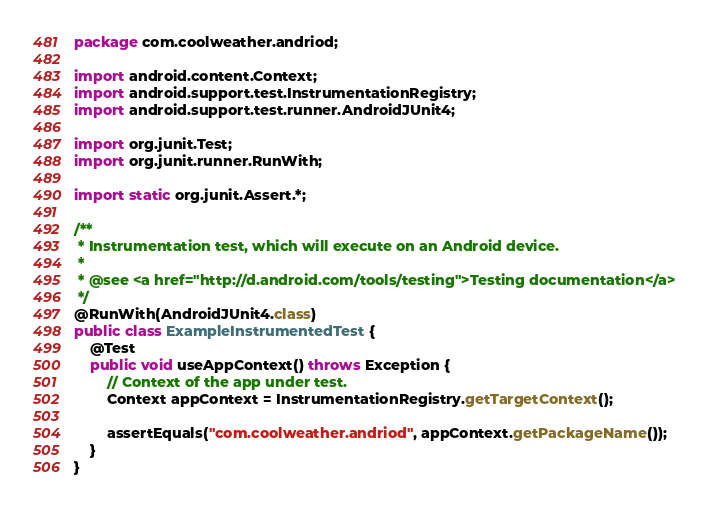Convert code to text. <code><loc_0><loc_0><loc_500><loc_500><_Java_>package com.coolweather.andriod;

import android.content.Context;
import android.support.test.InstrumentationRegistry;
import android.support.test.runner.AndroidJUnit4;

import org.junit.Test;
import org.junit.runner.RunWith;

import static org.junit.Assert.*;

/**
 * Instrumentation test, which will execute on an Android device.
 *
 * @see <a href="http://d.android.com/tools/testing">Testing documentation</a>
 */
@RunWith(AndroidJUnit4.class)
public class ExampleInstrumentedTest {
    @Test
    public void useAppContext() throws Exception {
        // Context of the app under test.
        Context appContext = InstrumentationRegistry.getTargetContext();

        assertEquals("com.coolweather.andriod", appContext.getPackageName());
    }
}
</code> 